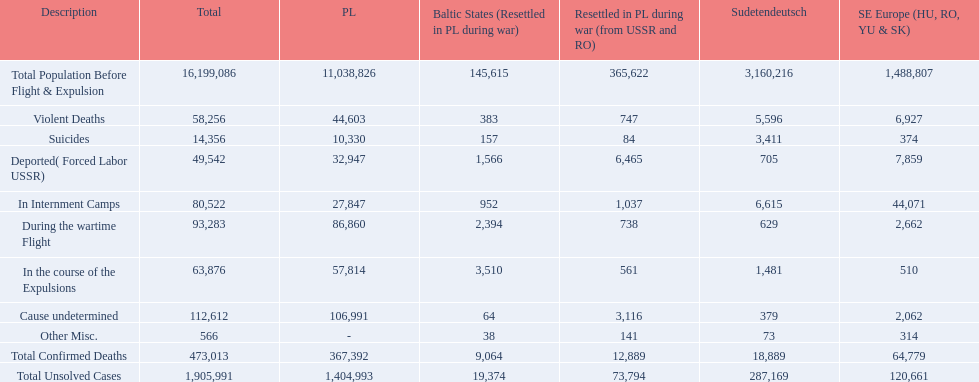Would you be able to parse every entry in this table? {'header': ['Description', 'Total', 'PL', 'Baltic States (Resettled in PL during war)', 'Resettled in PL during war (from USSR and RO)', 'Sudetendeutsch', 'SE Europe (HU, RO, YU & SK)'], 'rows': [['Total Population Before Flight & Expulsion', '16,199,086', '11,038,826', '145,615', '365,622', '3,160,216', '1,488,807'], ['Violent Deaths', '58,256', '44,603', '383', '747', '5,596', '6,927'], ['Suicides', '14,356', '10,330', '157', '84', '3,411', '374'], ['Deported( Forced Labor USSR)', '49,542', '32,947', '1,566', '6,465', '705', '7,859'], ['In Internment Camps', '80,522', '27,847', '952', '1,037', '6,615', '44,071'], ['During the wartime Flight', '93,283', '86,860', '2,394', '738', '629', '2,662'], ['In the course of the Expulsions', '63,876', '57,814', '3,510', '561', '1,481', '510'], ['Cause undetermined', '112,612', '106,991', '64', '3,116', '379', '2,062'], ['Other Misc.', '566', '-', '38', '141', '73', '314'], ['Total Confirmed Deaths', '473,013', '367,392', '9,064', '12,889', '18,889', '64,779'], ['Total Unsolved Cases', '1,905,991', '1,404,993', '19,374', '73,794', '287,169', '120,661']]} What were all of the types of deaths? Violent Deaths, Suicides, Deported( Forced Labor USSR), In Internment Camps, During the wartime Flight, In the course of the Expulsions, Cause undetermined, Other Misc. And their totals in the baltic states? 383, 157, 1,566, 952, 2,394, 3,510, 64, 38. Were more deaths in the baltic states caused by undetermined causes or misc.? Cause undetermined. 